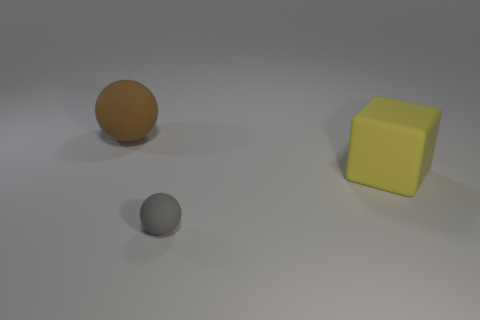Add 1 small purple cylinders. How many objects exist? 4 Subtract all balls. How many objects are left? 1 Add 1 yellow rubber cubes. How many yellow rubber cubes exist? 2 Subtract 0 red blocks. How many objects are left? 3 Subtract all small yellow objects. Subtract all big yellow matte things. How many objects are left? 2 Add 1 yellow cubes. How many yellow cubes are left? 2 